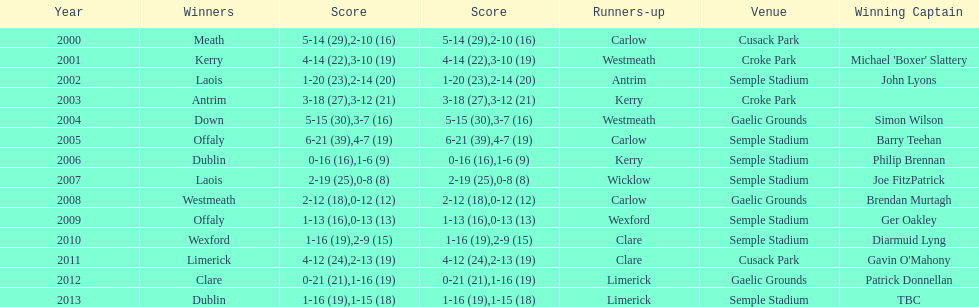What is the total number of times the competition was held at the semple stadium venue? 7. 